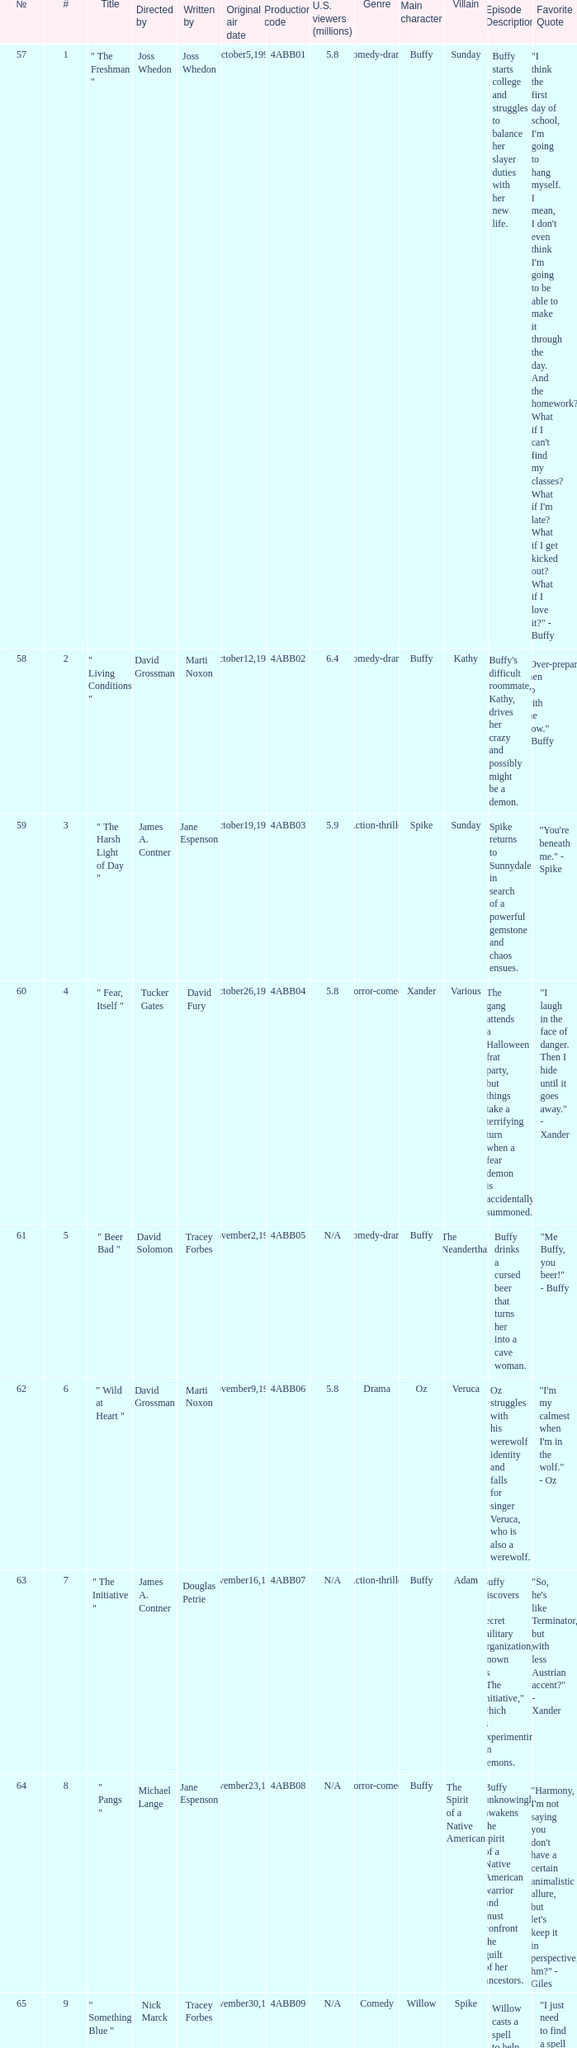What is the season 4 # for the production code of 4abb07? 7.0. 